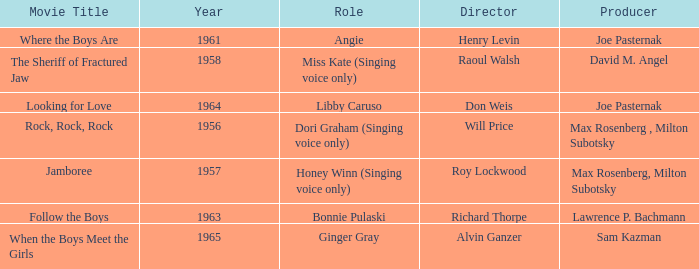Jamboree was made in what year? 1957.0. 